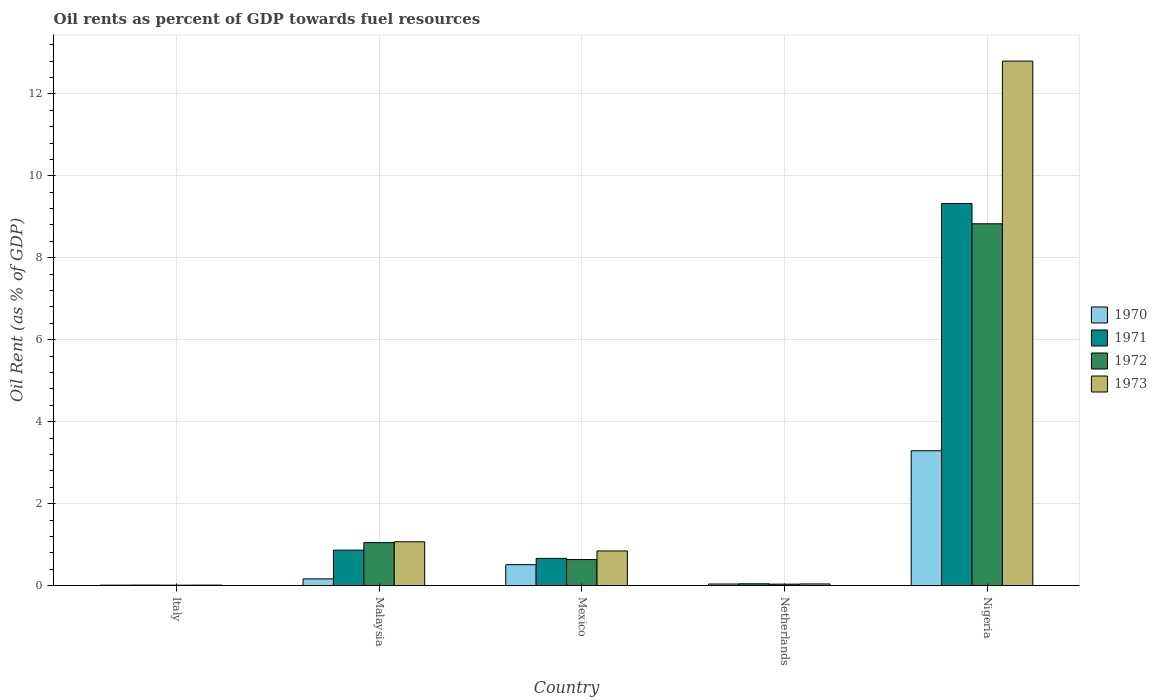How many different coloured bars are there?
Your answer should be compact. 4. Are the number of bars per tick equal to the number of legend labels?
Your answer should be compact. Yes. Are the number of bars on each tick of the X-axis equal?
Make the answer very short. Yes. How many bars are there on the 5th tick from the right?
Keep it short and to the point. 4. What is the label of the 4th group of bars from the left?
Your response must be concise. Netherlands. What is the oil rent in 1971 in Netherlands?
Offer a terse response. 0.04. Across all countries, what is the maximum oil rent in 1973?
Your answer should be compact. 12.8. Across all countries, what is the minimum oil rent in 1972?
Make the answer very short. 0.01. In which country was the oil rent in 1972 maximum?
Ensure brevity in your answer.  Nigeria. In which country was the oil rent in 1970 minimum?
Provide a succinct answer. Italy. What is the total oil rent in 1971 in the graph?
Ensure brevity in your answer.  10.91. What is the difference between the oil rent in 1970 in Mexico and that in Nigeria?
Your response must be concise. -2.78. What is the difference between the oil rent in 1972 in Malaysia and the oil rent in 1973 in Mexico?
Give a very brief answer. 0.2. What is the average oil rent in 1971 per country?
Make the answer very short. 2.18. What is the difference between the oil rent of/in 1972 and oil rent of/in 1970 in Nigeria?
Make the answer very short. 5.54. In how many countries, is the oil rent in 1971 greater than 12 %?
Your response must be concise. 0. What is the ratio of the oil rent in 1972 in Malaysia to that in Mexico?
Offer a very short reply. 1.65. What is the difference between the highest and the second highest oil rent in 1973?
Your answer should be very brief. -0.22. What is the difference between the highest and the lowest oil rent in 1971?
Keep it short and to the point. 9.31. In how many countries, is the oil rent in 1971 greater than the average oil rent in 1971 taken over all countries?
Your response must be concise. 1. Is the sum of the oil rent in 1972 in Italy and Netherlands greater than the maximum oil rent in 1970 across all countries?
Keep it short and to the point. No. What does the 1st bar from the left in Nigeria represents?
Keep it short and to the point. 1970. What does the 3rd bar from the right in Italy represents?
Make the answer very short. 1971. How many bars are there?
Your answer should be compact. 20. What is the difference between two consecutive major ticks on the Y-axis?
Ensure brevity in your answer.  2. Are the values on the major ticks of Y-axis written in scientific E-notation?
Your answer should be compact. No. Does the graph contain grids?
Your answer should be very brief. Yes. Where does the legend appear in the graph?
Give a very brief answer. Center right. How are the legend labels stacked?
Make the answer very short. Vertical. What is the title of the graph?
Ensure brevity in your answer.  Oil rents as percent of GDP towards fuel resources. What is the label or title of the Y-axis?
Provide a succinct answer. Oil Rent (as % of GDP). What is the Oil Rent (as % of GDP) in 1970 in Italy?
Your answer should be compact. 0.01. What is the Oil Rent (as % of GDP) of 1971 in Italy?
Your answer should be very brief. 0.01. What is the Oil Rent (as % of GDP) of 1972 in Italy?
Give a very brief answer. 0.01. What is the Oil Rent (as % of GDP) of 1973 in Italy?
Provide a short and direct response. 0.01. What is the Oil Rent (as % of GDP) of 1970 in Malaysia?
Provide a short and direct response. 0.16. What is the Oil Rent (as % of GDP) in 1971 in Malaysia?
Your answer should be very brief. 0.86. What is the Oil Rent (as % of GDP) of 1972 in Malaysia?
Keep it short and to the point. 1.05. What is the Oil Rent (as % of GDP) in 1973 in Malaysia?
Your answer should be very brief. 1.07. What is the Oil Rent (as % of GDP) in 1970 in Mexico?
Your answer should be compact. 0.51. What is the Oil Rent (as % of GDP) in 1971 in Mexico?
Offer a very short reply. 0.66. What is the Oil Rent (as % of GDP) of 1972 in Mexico?
Offer a terse response. 0.63. What is the Oil Rent (as % of GDP) in 1973 in Mexico?
Your answer should be compact. 0.84. What is the Oil Rent (as % of GDP) of 1970 in Netherlands?
Ensure brevity in your answer.  0.04. What is the Oil Rent (as % of GDP) in 1971 in Netherlands?
Keep it short and to the point. 0.04. What is the Oil Rent (as % of GDP) of 1972 in Netherlands?
Ensure brevity in your answer.  0.03. What is the Oil Rent (as % of GDP) of 1973 in Netherlands?
Offer a very short reply. 0.04. What is the Oil Rent (as % of GDP) in 1970 in Nigeria?
Ensure brevity in your answer.  3.29. What is the Oil Rent (as % of GDP) of 1971 in Nigeria?
Your answer should be very brief. 9.32. What is the Oil Rent (as % of GDP) of 1972 in Nigeria?
Ensure brevity in your answer.  8.83. What is the Oil Rent (as % of GDP) of 1973 in Nigeria?
Ensure brevity in your answer.  12.8. Across all countries, what is the maximum Oil Rent (as % of GDP) in 1970?
Provide a short and direct response. 3.29. Across all countries, what is the maximum Oil Rent (as % of GDP) in 1971?
Offer a very short reply. 9.32. Across all countries, what is the maximum Oil Rent (as % of GDP) of 1972?
Provide a short and direct response. 8.83. Across all countries, what is the maximum Oil Rent (as % of GDP) in 1973?
Your answer should be very brief. 12.8. Across all countries, what is the minimum Oil Rent (as % of GDP) in 1970?
Give a very brief answer. 0.01. Across all countries, what is the minimum Oil Rent (as % of GDP) in 1971?
Provide a short and direct response. 0.01. Across all countries, what is the minimum Oil Rent (as % of GDP) of 1972?
Keep it short and to the point. 0.01. Across all countries, what is the minimum Oil Rent (as % of GDP) in 1973?
Ensure brevity in your answer.  0.01. What is the total Oil Rent (as % of GDP) of 1970 in the graph?
Ensure brevity in your answer.  4.01. What is the total Oil Rent (as % of GDP) of 1971 in the graph?
Offer a very short reply. 10.91. What is the total Oil Rent (as % of GDP) of 1972 in the graph?
Your answer should be very brief. 10.56. What is the total Oil Rent (as % of GDP) of 1973 in the graph?
Provide a succinct answer. 14.76. What is the difference between the Oil Rent (as % of GDP) in 1970 in Italy and that in Malaysia?
Offer a very short reply. -0.15. What is the difference between the Oil Rent (as % of GDP) in 1971 in Italy and that in Malaysia?
Provide a short and direct response. -0.85. What is the difference between the Oil Rent (as % of GDP) in 1972 in Italy and that in Malaysia?
Provide a succinct answer. -1.04. What is the difference between the Oil Rent (as % of GDP) in 1973 in Italy and that in Malaysia?
Make the answer very short. -1.06. What is the difference between the Oil Rent (as % of GDP) of 1970 in Italy and that in Mexico?
Ensure brevity in your answer.  -0.5. What is the difference between the Oil Rent (as % of GDP) of 1971 in Italy and that in Mexico?
Provide a short and direct response. -0.65. What is the difference between the Oil Rent (as % of GDP) in 1972 in Italy and that in Mexico?
Provide a succinct answer. -0.63. What is the difference between the Oil Rent (as % of GDP) of 1973 in Italy and that in Mexico?
Your answer should be very brief. -0.83. What is the difference between the Oil Rent (as % of GDP) of 1970 in Italy and that in Netherlands?
Keep it short and to the point. -0.03. What is the difference between the Oil Rent (as % of GDP) of 1971 in Italy and that in Netherlands?
Offer a terse response. -0.03. What is the difference between the Oil Rent (as % of GDP) of 1972 in Italy and that in Netherlands?
Provide a short and direct response. -0.03. What is the difference between the Oil Rent (as % of GDP) in 1973 in Italy and that in Netherlands?
Your response must be concise. -0.03. What is the difference between the Oil Rent (as % of GDP) in 1970 in Italy and that in Nigeria?
Provide a succinct answer. -3.28. What is the difference between the Oil Rent (as % of GDP) in 1971 in Italy and that in Nigeria?
Your response must be concise. -9.31. What is the difference between the Oil Rent (as % of GDP) in 1972 in Italy and that in Nigeria?
Make the answer very short. -8.82. What is the difference between the Oil Rent (as % of GDP) in 1973 in Italy and that in Nigeria?
Give a very brief answer. -12.79. What is the difference between the Oil Rent (as % of GDP) of 1970 in Malaysia and that in Mexico?
Provide a short and direct response. -0.35. What is the difference between the Oil Rent (as % of GDP) in 1971 in Malaysia and that in Mexico?
Make the answer very short. 0.2. What is the difference between the Oil Rent (as % of GDP) in 1972 in Malaysia and that in Mexico?
Keep it short and to the point. 0.41. What is the difference between the Oil Rent (as % of GDP) in 1973 in Malaysia and that in Mexico?
Keep it short and to the point. 0.22. What is the difference between the Oil Rent (as % of GDP) in 1970 in Malaysia and that in Netherlands?
Keep it short and to the point. 0.13. What is the difference between the Oil Rent (as % of GDP) of 1971 in Malaysia and that in Netherlands?
Your answer should be compact. 0.82. What is the difference between the Oil Rent (as % of GDP) in 1972 in Malaysia and that in Netherlands?
Keep it short and to the point. 1.01. What is the difference between the Oil Rent (as % of GDP) in 1973 in Malaysia and that in Netherlands?
Your answer should be very brief. 1.03. What is the difference between the Oil Rent (as % of GDP) of 1970 in Malaysia and that in Nigeria?
Your answer should be very brief. -3.13. What is the difference between the Oil Rent (as % of GDP) of 1971 in Malaysia and that in Nigeria?
Make the answer very short. -8.46. What is the difference between the Oil Rent (as % of GDP) of 1972 in Malaysia and that in Nigeria?
Your answer should be compact. -7.78. What is the difference between the Oil Rent (as % of GDP) of 1973 in Malaysia and that in Nigeria?
Your response must be concise. -11.73. What is the difference between the Oil Rent (as % of GDP) in 1970 in Mexico and that in Netherlands?
Your answer should be compact. 0.47. What is the difference between the Oil Rent (as % of GDP) of 1971 in Mexico and that in Netherlands?
Provide a short and direct response. 0.62. What is the difference between the Oil Rent (as % of GDP) of 1972 in Mexico and that in Netherlands?
Make the answer very short. 0.6. What is the difference between the Oil Rent (as % of GDP) in 1973 in Mexico and that in Netherlands?
Offer a terse response. 0.81. What is the difference between the Oil Rent (as % of GDP) in 1970 in Mexico and that in Nigeria?
Provide a succinct answer. -2.78. What is the difference between the Oil Rent (as % of GDP) of 1971 in Mexico and that in Nigeria?
Your response must be concise. -8.66. What is the difference between the Oil Rent (as % of GDP) in 1972 in Mexico and that in Nigeria?
Keep it short and to the point. -8.19. What is the difference between the Oil Rent (as % of GDP) in 1973 in Mexico and that in Nigeria?
Offer a terse response. -11.95. What is the difference between the Oil Rent (as % of GDP) of 1970 in Netherlands and that in Nigeria?
Ensure brevity in your answer.  -3.25. What is the difference between the Oil Rent (as % of GDP) of 1971 in Netherlands and that in Nigeria?
Your response must be concise. -9.28. What is the difference between the Oil Rent (as % of GDP) in 1972 in Netherlands and that in Nigeria?
Provide a succinct answer. -8.79. What is the difference between the Oil Rent (as % of GDP) of 1973 in Netherlands and that in Nigeria?
Ensure brevity in your answer.  -12.76. What is the difference between the Oil Rent (as % of GDP) in 1970 in Italy and the Oil Rent (as % of GDP) in 1971 in Malaysia?
Your answer should be very brief. -0.85. What is the difference between the Oil Rent (as % of GDP) in 1970 in Italy and the Oil Rent (as % of GDP) in 1972 in Malaysia?
Offer a very short reply. -1.04. What is the difference between the Oil Rent (as % of GDP) in 1970 in Italy and the Oil Rent (as % of GDP) in 1973 in Malaysia?
Give a very brief answer. -1.06. What is the difference between the Oil Rent (as % of GDP) in 1971 in Italy and the Oil Rent (as % of GDP) in 1972 in Malaysia?
Keep it short and to the point. -1.04. What is the difference between the Oil Rent (as % of GDP) in 1971 in Italy and the Oil Rent (as % of GDP) in 1973 in Malaysia?
Your answer should be compact. -1.06. What is the difference between the Oil Rent (as % of GDP) of 1972 in Italy and the Oil Rent (as % of GDP) of 1973 in Malaysia?
Offer a very short reply. -1.06. What is the difference between the Oil Rent (as % of GDP) in 1970 in Italy and the Oil Rent (as % of GDP) in 1971 in Mexico?
Make the answer very short. -0.65. What is the difference between the Oil Rent (as % of GDP) in 1970 in Italy and the Oil Rent (as % of GDP) in 1972 in Mexico?
Your response must be concise. -0.62. What is the difference between the Oil Rent (as % of GDP) in 1970 in Italy and the Oil Rent (as % of GDP) in 1973 in Mexico?
Your answer should be compact. -0.83. What is the difference between the Oil Rent (as % of GDP) in 1971 in Italy and the Oil Rent (as % of GDP) in 1972 in Mexico?
Ensure brevity in your answer.  -0.62. What is the difference between the Oil Rent (as % of GDP) in 1971 in Italy and the Oil Rent (as % of GDP) in 1973 in Mexico?
Make the answer very short. -0.83. What is the difference between the Oil Rent (as % of GDP) of 1972 in Italy and the Oil Rent (as % of GDP) of 1973 in Mexico?
Offer a terse response. -0.84. What is the difference between the Oil Rent (as % of GDP) of 1970 in Italy and the Oil Rent (as % of GDP) of 1971 in Netherlands?
Offer a very short reply. -0.03. What is the difference between the Oil Rent (as % of GDP) in 1970 in Italy and the Oil Rent (as % of GDP) in 1972 in Netherlands?
Your answer should be compact. -0.02. What is the difference between the Oil Rent (as % of GDP) of 1970 in Italy and the Oil Rent (as % of GDP) of 1973 in Netherlands?
Your answer should be very brief. -0.03. What is the difference between the Oil Rent (as % of GDP) in 1971 in Italy and the Oil Rent (as % of GDP) in 1972 in Netherlands?
Ensure brevity in your answer.  -0.02. What is the difference between the Oil Rent (as % of GDP) in 1971 in Italy and the Oil Rent (as % of GDP) in 1973 in Netherlands?
Provide a short and direct response. -0.03. What is the difference between the Oil Rent (as % of GDP) in 1972 in Italy and the Oil Rent (as % of GDP) in 1973 in Netherlands?
Keep it short and to the point. -0.03. What is the difference between the Oil Rent (as % of GDP) of 1970 in Italy and the Oil Rent (as % of GDP) of 1971 in Nigeria?
Keep it short and to the point. -9.31. What is the difference between the Oil Rent (as % of GDP) of 1970 in Italy and the Oil Rent (as % of GDP) of 1972 in Nigeria?
Provide a short and direct response. -8.82. What is the difference between the Oil Rent (as % of GDP) of 1970 in Italy and the Oil Rent (as % of GDP) of 1973 in Nigeria?
Offer a terse response. -12.79. What is the difference between the Oil Rent (as % of GDP) of 1971 in Italy and the Oil Rent (as % of GDP) of 1972 in Nigeria?
Your answer should be very brief. -8.82. What is the difference between the Oil Rent (as % of GDP) of 1971 in Italy and the Oil Rent (as % of GDP) of 1973 in Nigeria?
Your answer should be very brief. -12.79. What is the difference between the Oil Rent (as % of GDP) in 1972 in Italy and the Oil Rent (as % of GDP) in 1973 in Nigeria?
Provide a short and direct response. -12.79. What is the difference between the Oil Rent (as % of GDP) in 1970 in Malaysia and the Oil Rent (as % of GDP) in 1971 in Mexico?
Provide a short and direct response. -0.5. What is the difference between the Oil Rent (as % of GDP) in 1970 in Malaysia and the Oil Rent (as % of GDP) in 1972 in Mexico?
Ensure brevity in your answer.  -0.47. What is the difference between the Oil Rent (as % of GDP) in 1970 in Malaysia and the Oil Rent (as % of GDP) in 1973 in Mexico?
Make the answer very short. -0.68. What is the difference between the Oil Rent (as % of GDP) of 1971 in Malaysia and the Oil Rent (as % of GDP) of 1972 in Mexico?
Keep it short and to the point. 0.23. What is the difference between the Oil Rent (as % of GDP) of 1971 in Malaysia and the Oil Rent (as % of GDP) of 1973 in Mexico?
Offer a very short reply. 0.02. What is the difference between the Oil Rent (as % of GDP) in 1972 in Malaysia and the Oil Rent (as % of GDP) in 1973 in Mexico?
Your answer should be compact. 0.2. What is the difference between the Oil Rent (as % of GDP) in 1970 in Malaysia and the Oil Rent (as % of GDP) in 1971 in Netherlands?
Ensure brevity in your answer.  0.12. What is the difference between the Oil Rent (as % of GDP) in 1970 in Malaysia and the Oil Rent (as % of GDP) in 1972 in Netherlands?
Your response must be concise. 0.13. What is the difference between the Oil Rent (as % of GDP) in 1970 in Malaysia and the Oil Rent (as % of GDP) in 1973 in Netherlands?
Provide a succinct answer. 0.12. What is the difference between the Oil Rent (as % of GDP) of 1971 in Malaysia and the Oil Rent (as % of GDP) of 1972 in Netherlands?
Ensure brevity in your answer.  0.83. What is the difference between the Oil Rent (as % of GDP) in 1971 in Malaysia and the Oil Rent (as % of GDP) in 1973 in Netherlands?
Offer a terse response. 0.82. What is the difference between the Oil Rent (as % of GDP) in 1972 in Malaysia and the Oil Rent (as % of GDP) in 1973 in Netherlands?
Provide a succinct answer. 1.01. What is the difference between the Oil Rent (as % of GDP) in 1970 in Malaysia and the Oil Rent (as % of GDP) in 1971 in Nigeria?
Offer a terse response. -9.16. What is the difference between the Oil Rent (as % of GDP) in 1970 in Malaysia and the Oil Rent (as % of GDP) in 1972 in Nigeria?
Provide a succinct answer. -8.67. What is the difference between the Oil Rent (as % of GDP) in 1970 in Malaysia and the Oil Rent (as % of GDP) in 1973 in Nigeria?
Provide a succinct answer. -12.64. What is the difference between the Oil Rent (as % of GDP) in 1971 in Malaysia and the Oil Rent (as % of GDP) in 1972 in Nigeria?
Ensure brevity in your answer.  -7.96. What is the difference between the Oil Rent (as % of GDP) in 1971 in Malaysia and the Oil Rent (as % of GDP) in 1973 in Nigeria?
Make the answer very short. -11.94. What is the difference between the Oil Rent (as % of GDP) in 1972 in Malaysia and the Oil Rent (as % of GDP) in 1973 in Nigeria?
Your response must be concise. -11.75. What is the difference between the Oil Rent (as % of GDP) in 1970 in Mexico and the Oil Rent (as % of GDP) in 1971 in Netherlands?
Ensure brevity in your answer.  0.47. What is the difference between the Oil Rent (as % of GDP) in 1970 in Mexico and the Oil Rent (as % of GDP) in 1972 in Netherlands?
Your answer should be very brief. 0.47. What is the difference between the Oil Rent (as % of GDP) in 1970 in Mexico and the Oil Rent (as % of GDP) in 1973 in Netherlands?
Give a very brief answer. 0.47. What is the difference between the Oil Rent (as % of GDP) in 1971 in Mexico and the Oil Rent (as % of GDP) in 1972 in Netherlands?
Give a very brief answer. 0.63. What is the difference between the Oil Rent (as % of GDP) of 1971 in Mexico and the Oil Rent (as % of GDP) of 1973 in Netherlands?
Offer a terse response. 0.62. What is the difference between the Oil Rent (as % of GDP) in 1972 in Mexico and the Oil Rent (as % of GDP) in 1973 in Netherlands?
Your response must be concise. 0.6. What is the difference between the Oil Rent (as % of GDP) of 1970 in Mexico and the Oil Rent (as % of GDP) of 1971 in Nigeria?
Offer a very short reply. -8.81. What is the difference between the Oil Rent (as % of GDP) in 1970 in Mexico and the Oil Rent (as % of GDP) in 1972 in Nigeria?
Keep it short and to the point. -8.32. What is the difference between the Oil Rent (as % of GDP) of 1970 in Mexico and the Oil Rent (as % of GDP) of 1973 in Nigeria?
Your answer should be compact. -12.29. What is the difference between the Oil Rent (as % of GDP) of 1971 in Mexico and the Oil Rent (as % of GDP) of 1972 in Nigeria?
Keep it short and to the point. -8.17. What is the difference between the Oil Rent (as % of GDP) of 1971 in Mexico and the Oil Rent (as % of GDP) of 1973 in Nigeria?
Offer a terse response. -12.14. What is the difference between the Oil Rent (as % of GDP) of 1972 in Mexico and the Oil Rent (as % of GDP) of 1973 in Nigeria?
Your answer should be compact. -12.16. What is the difference between the Oil Rent (as % of GDP) in 1970 in Netherlands and the Oil Rent (as % of GDP) in 1971 in Nigeria?
Offer a terse response. -9.29. What is the difference between the Oil Rent (as % of GDP) in 1970 in Netherlands and the Oil Rent (as % of GDP) in 1972 in Nigeria?
Ensure brevity in your answer.  -8.79. What is the difference between the Oil Rent (as % of GDP) of 1970 in Netherlands and the Oil Rent (as % of GDP) of 1973 in Nigeria?
Your answer should be compact. -12.76. What is the difference between the Oil Rent (as % of GDP) of 1971 in Netherlands and the Oil Rent (as % of GDP) of 1972 in Nigeria?
Make the answer very short. -8.79. What is the difference between the Oil Rent (as % of GDP) in 1971 in Netherlands and the Oil Rent (as % of GDP) in 1973 in Nigeria?
Provide a short and direct response. -12.76. What is the difference between the Oil Rent (as % of GDP) of 1972 in Netherlands and the Oil Rent (as % of GDP) of 1973 in Nigeria?
Your answer should be compact. -12.76. What is the average Oil Rent (as % of GDP) of 1970 per country?
Your answer should be compact. 0.8. What is the average Oil Rent (as % of GDP) in 1971 per country?
Your answer should be compact. 2.18. What is the average Oil Rent (as % of GDP) in 1972 per country?
Provide a succinct answer. 2.11. What is the average Oil Rent (as % of GDP) of 1973 per country?
Give a very brief answer. 2.95. What is the difference between the Oil Rent (as % of GDP) in 1970 and Oil Rent (as % of GDP) in 1971 in Italy?
Offer a very short reply. -0. What is the difference between the Oil Rent (as % of GDP) of 1970 and Oil Rent (as % of GDP) of 1972 in Italy?
Your answer should be very brief. 0. What is the difference between the Oil Rent (as % of GDP) in 1970 and Oil Rent (as % of GDP) in 1973 in Italy?
Make the answer very short. -0. What is the difference between the Oil Rent (as % of GDP) of 1971 and Oil Rent (as % of GDP) of 1972 in Italy?
Give a very brief answer. 0. What is the difference between the Oil Rent (as % of GDP) of 1972 and Oil Rent (as % of GDP) of 1973 in Italy?
Your answer should be very brief. -0. What is the difference between the Oil Rent (as % of GDP) in 1970 and Oil Rent (as % of GDP) in 1971 in Malaysia?
Keep it short and to the point. -0.7. What is the difference between the Oil Rent (as % of GDP) in 1970 and Oil Rent (as % of GDP) in 1972 in Malaysia?
Your answer should be very brief. -0.89. What is the difference between the Oil Rent (as % of GDP) in 1970 and Oil Rent (as % of GDP) in 1973 in Malaysia?
Provide a short and direct response. -0.91. What is the difference between the Oil Rent (as % of GDP) of 1971 and Oil Rent (as % of GDP) of 1972 in Malaysia?
Offer a very short reply. -0.18. What is the difference between the Oil Rent (as % of GDP) of 1971 and Oil Rent (as % of GDP) of 1973 in Malaysia?
Ensure brevity in your answer.  -0.2. What is the difference between the Oil Rent (as % of GDP) of 1972 and Oil Rent (as % of GDP) of 1973 in Malaysia?
Your answer should be very brief. -0.02. What is the difference between the Oil Rent (as % of GDP) in 1970 and Oil Rent (as % of GDP) in 1971 in Mexico?
Your answer should be very brief. -0.15. What is the difference between the Oil Rent (as % of GDP) of 1970 and Oil Rent (as % of GDP) of 1972 in Mexico?
Provide a succinct answer. -0.13. What is the difference between the Oil Rent (as % of GDP) of 1970 and Oil Rent (as % of GDP) of 1973 in Mexico?
Provide a succinct answer. -0.34. What is the difference between the Oil Rent (as % of GDP) in 1971 and Oil Rent (as % of GDP) in 1972 in Mexico?
Your answer should be very brief. 0.03. What is the difference between the Oil Rent (as % of GDP) of 1971 and Oil Rent (as % of GDP) of 1973 in Mexico?
Ensure brevity in your answer.  -0.18. What is the difference between the Oil Rent (as % of GDP) in 1972 and Oil Rent (as % of GDP) in 1973 in Mexico?
Provide a succinct answer. -0.21. What is the difference between the Oil Rent (as % of GDP) in 1970 and Oil Rent (as % of GDP) in 1971 in Netherlands?
Ensure brevity in your answer.  -0.01. What is the difference between the Oil Rent (as % of GDP) of 1970 and Oil Rent (as % of GDP) of 1972 in Netherlands?
Give a very brief answer. 0. What is the difference between the Oil Rent (as % of GDP) in 1970 and Oil Rent (as % of GDP) in 1973 in Netherlands?
Your answer should be compact. -0. What is the difference between the Oil Rent (as % of GDP) of 1971 and Oil Rent (as % of GDP) of 1972 in Netherlands?
Ensure brevity in your answer.  0.01. What is the difference between the Oil Rent (as % of GDP) in 1971 and Oil Rent (as % of GDP) in 1973 in Netherlands?
Offer a very short reply. 0. What is the difference between the Oil Rent (as % of GDP) in 1972 and Oil Rent (as % of GDP) in 1973 in Netherlands?
Provide a short and direct response. -0. What is the difference between the Oil Rent (as % of GDP) of 1970 and Oil Rent (as % of GDP) of 1971 in Nigeria?
Give a very brief answer. -6.03. What is the difference between the Oil Rent (as % of GDP) of 1970 and Oil Rent (as % of GDP) of 1972 in Nigeria?
Offer a terse response. -5.54. What is the difference between the Oil Rent (as % of GDP) of 1970 and Oil Rent (as % of GDP) of 1973 in Nigeria?
Offer a very short reply. -9.51. What is the difference between the Oil Rent (as % of GDP) in 1971 and Oil Rent (as % of GDP) in 1972 in Nigeria?
Offer a terse response. 0.49. What is the difference between the Oil Rent (as % of GDP) in 1971 and Oil Rent (as % of GDP) in 1973 in Nigeria?
Provide a succinct answer. -3.48. What is the difference between the Oil Rent (as % of GDP) of 1972 and Oil Rent (as % of GDP) of 1973 in Nigeria?
Offer a terse response. -3.97. What is the ratio of the Oil Rent (as % of GDP) in 1970 in Italy to that in Malaysia?
Keep it short and to the point. 0.06. What is the ratio of the Oil Rent (as % of GDP) in 1971 in Italy to that in Malaysia?
Your response must be concise. 0.01. What is the ratio of the Oil Rent (as % of GDP) of 1972 in Italy to that in Malaysia?
Give a very brief answer. 0.01. What is the ratio of the Oil Rent (as % of GDP) of 1973 in Italy to that in Malaysia?
Keep it short and to the point. 0.01. What is the ratio of the Oil Rent (as % of GDP) of 1970 in Italy to that in Mexico?
Keep it short and to the point. 0.02. What is the ratio of the Oil Rent (as % of GDP) in 1971 in Italy to that in Mexico?
Ensure brevity in your answer.  0.02. What is the ratio of the Oil Rent (as % of GDP) in 1972 in Italy to that in Mexico?
Provide a succinct answer. 0.01. What is the ratio of the Oil Rent (as % of GDP) in 1973 in Italy to that in Mexico?
Offer a very short reply. 0.01. What is the ratio of the Oil Rent (as % of GDP) in 1970 in Italy to that in Netherlands?
Ensure brevity in your answer.  0.26. What is the ratio of the Oil Rent (as % of GDP) of 1971 in Italy to that in Netherlands?
Ensure brevity in your answer.  0.27. What is the ratio of the Oil Rent (as % of GDP) of 1972 in Italy to that in Netherlands?
Provide a short and direct response. 0.27. What is the ratio of the Oil Rent (as % of GDP) in 1973 in Italy to that in Netherlands?
Your response must be concise. 0.28. What is the ratio of the Oil Rent (as % of GDP) in 1970 in Italy to that in Nigeria?
Provide a short and direct response. 0. What is the ratio of the Oil Rent (as % of GDP) in 1971 in Italy to that in Nigeria?
Give a very brief answer. 0. What is the ratio of the Oil Rent (as % of GDP) in 1972 in Italy to that in Nigeria?
Keep it short and to the point. 0. What is the ratio of the Oil Rent (as % of GDP) of 1973 in Italy to that in Nigeria?
Your response must be concise. 0. What is the ratio of the Oil Rent (as % of GDP) in 1970 in Malaysia to that in Mexico?
Give a very brief answer. 0.32. What is the ratio of the Oil Rent (as % of GDP) in 1971 in Malaysia to that in Mexico?
Give a very brief answer. 1.3. What is the ratio of the Oil Rent (as % of GDP) of 1972 in Malaysia to that in Mexico?
Offer a very short reply. 1.65. What is the ratio of the Oil Rent (as % of GDP) in 1973 in Malaysia to that in Mexico?
Your answer should be compact. 1.27. What is the ratio of the Oil Rent (as % of GDP) of 1970 in Malaysia to that in Netherlands?
Your answer should be very brief. 4.3. What is the ratio of the Oil Rent (as % of GDP) of 1971 in Malaysia to that in Netherlands?
Your response must be concise. 20.04. What is the ratio of the Oil Rent (as % of GDP) in 1972 in Malaysia to that in Netherlands?
Ensure brevity in your answer.  30.19. What is the ratio of the Oil Rent (as % of GDP) in 1973 in Malaysia to that in Netherlands?
Offer a terse response. 27.06. What is the ratio of the Oil Rent (as % of GDP) of 1970 in Malaysia to that in Nigeria?
Give a very brief answer. 0.05. What is the ratio of the Oil Rent (as % of GDP) in 1971 in Malaysia to that in Nigeria?
Offer a terse response. 0.09. What is the ratio of the Oil Rent (as % of GDP) of 1972 in Malaysia to that in Nigeria?
Provide a short and direct response. 0.12. What is the ratio of the Oil Rent (as % of GDP) of 1973 in Malaysia to that in Nigeria?
Your answer should be very brief. 0.08. What is the ratio of the Oil Rent (as % of GDP) of 1970 in Mexico to that in Netherlands?
Make the answer very short. 13.43. What is the ratio of the Oil Rent (as % of GDP) of 1971 in Mexico to that in Netherlands?
Your answer should be compact. 15.37. What is the ratio of the Oil Rent (as % of GDP) of 1972 in Mexico to that in Netherlands?
Your response must be concise. 18.28. What is the ratio of the Oil Rent (as % of GDP) of 1973 in Mexico to that in Netherlands?
Ensure brevity in your answer.  21.38. What is the ratio of the Oil Rent (as % of GDP) of 1970 in Mexico to that in Nigeria?
Give a very brief answer. 0.15. What is the ratio of the Oil Rent (as % of GDP) of 1971 in Mexico to that in Nigeria?
Ensure brevity in your answer.  0.07. What is the ratio of the Oil Rent (as % of GDP) of 1972 in Mexico to that in Nigeria?
Keep it short and to the point. 0.07. What is the ratio of the Oil Rent (as % of GDP) in 1973 in Mexico to that in Nigeria?
Provide a short and direct response. 0.07. What is the ratio of the Oil Rent (as % of GDP) of 1970 in Netherlands to that in Nigeria?
Make the answer very short. 0.01. What is the ratio of the Oil Rent (as % of GDP) in 1971 in Netherlands to that in Nigeria?
Offer a terse response. 0. What is the ratio of the Oil Rent (as % of GDP) of 1972 in Netherlands to that in Nigeria?
Provide a succinct answer. 0. What is the ratio of the Oil Rent (as % of GDP) of 1973 in Netherlands to that in Nigeria?
Your answer should be very brief. 0. What is the difference between the highest and the second highest Oil Rent (as % of GDP) of 1970?
Give a very brief answer. 2.78. What is the difference between the highest and the second highest Oil Rent (as % of GDP) in 1971?
Your response must be concise. 8.46. What is the difference between the highest and the second highest Oil Rent (as % of GDP) in 1972?
Your response must be concise. 7.78. What is the difference between the highest and the second highest Oil Rent (as % of GDP) of 1973?
Provide a short and direct response. 11.73. What is the difference between the highest and the lowest Oil Rent (as % of GDP) in 1970?
Keep it short and to the point. 3.28. What is the difference between the highest and the lowest Oil Rent (as % of GDP) of 1971?
Your answer should be very brief. 9.31. What is the difference between the highest and the lowest Oil Rent (as % of GDP) in 1972?
Keep it short and to the point. 8.82. What is the difference between the highest and the lowest Oil Rent (as % of GDP) of 1973?
Ensure brevity in your answer.  12.79. 